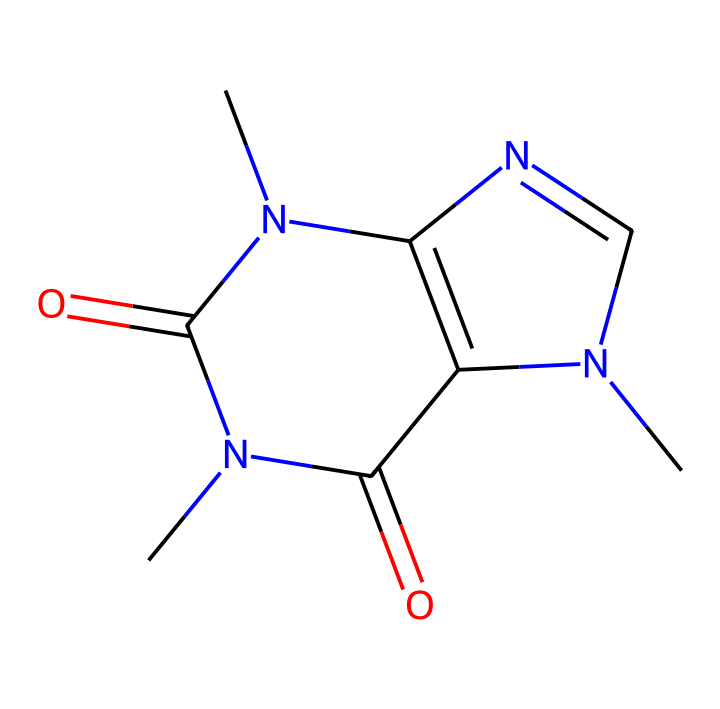What is the molecular formula of caffeine? By analyzing the structure represented by the SMILES notation, we can count the atoms of each element present. Caffeine contains 8 carbon (C) atoms, 10 hydrogen (H) atoms, 4 nitrogen (N) atoms, and 2 oxygen (O) atoms, leading to the molecular formula C8H10N4O2.
Answer: C8H10N4O2 How many rings are present in caffeine's structure? The structure of caffeine features two fused rings, which can be identified by looking for the cyclic components within the SMILES representation. Each ring contributes to the overall bicyclic nature of the molecule.
Answer: 2 What type of nitrogen compounds are present in caffeine? Upon examining the structure, we identify that caffeine contains both amine (NH) and amide (C=O-NH) groups based on the presence of nitrogen with attached carbon and oxygen. This indicates a mixture of these nitrogen functionalities within the compound.
Answer: amine and amide Is caffeine a stimulant or a depressant? The molecular structure of caffeine shows the presence of nitrogen atoms and its psychoactive properties, indicating it's known as a stimulant. Caffeine is widely recognized for its ability to increase alertness and act as a central nervous system stimulant.
Answer: stimulant What is the characteristic functional group in caffeine? The structure of caffeine includes multiple functional groups, but the most distinct and significant one is the amide functional group, which plays a crucial role in its biochemical activity. This group is recognized by the carbonyl (C=O) bonded to nitrogen (N).
Answer: amide How many total atoms are in the caffeine molecule? To determine the total number of atoms, we add the number of each type of atom from the molecular formula: 8 carbon + 10 hydrogen + 4 nitrogen + 2 oxygen = 24 total atoms. Thus, the overall count reflects the sum of these individual contributions.
Answer: 24 